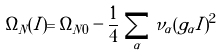<formula> <loc_0><loc_0><loc_500><loc_500>\Omega _ { N } ( I ) = \Omega _ { N 0 } - \frac { 1 } { 4 } \, \sum _ { \alpha } \nu _ { \alpha } ( g _ { \alpha } I ) ^ { 2 }</formula> 